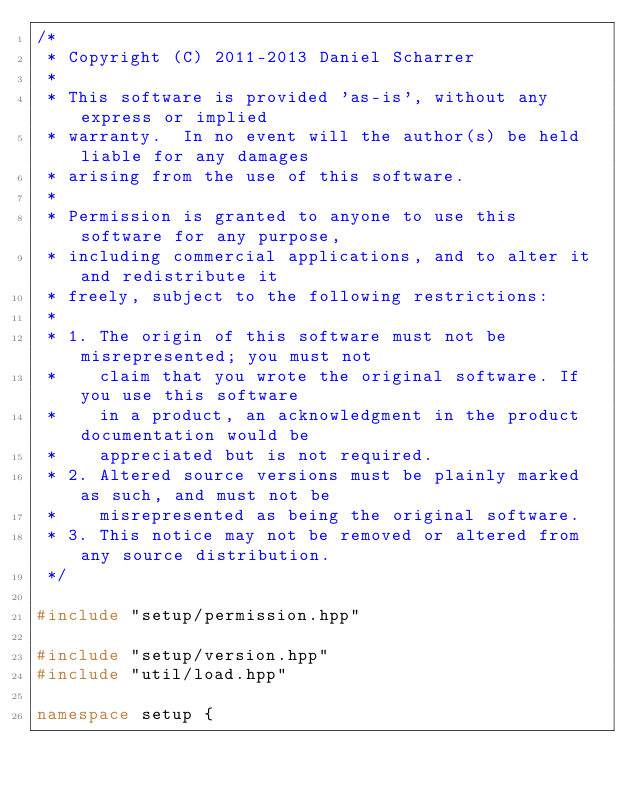Convert code to text. <code><loc_0><loc_0><loc_500><loc_500><_C++_>/*
 * Copyright (C) 2011-2013 Daniel Scharrer
 *
 * This software is provided 'as-is', without any express or implied
 * warranty.  In no event will the author(s) be held liable for any damages
 * arising from the use of this software.
 *
 * Permission is granted to anyone to use this software for any purpose,
 * including commercial applications, and to alter it and redistribute it
 * freely, subject to the following restrictions:
 *
 * 1. The origin of this software must not be misrepresented; you must not
 *    claim that you wrote the original software. If you use this software
 *    in a product, an acknowledgment in the product documentation would be
 *    appreciated but is not required.
 * 2. Altered source versions must be plainly marked as such, and must not be
 *    misrepresented as being the original software.
 * 3. This notice may not be removed or altered from any source distribution.
 */

#include "setup/permission.hpp"

#include "setup/version.hpp"
#include "util/load.hpp"

namespace setup {
</code> 